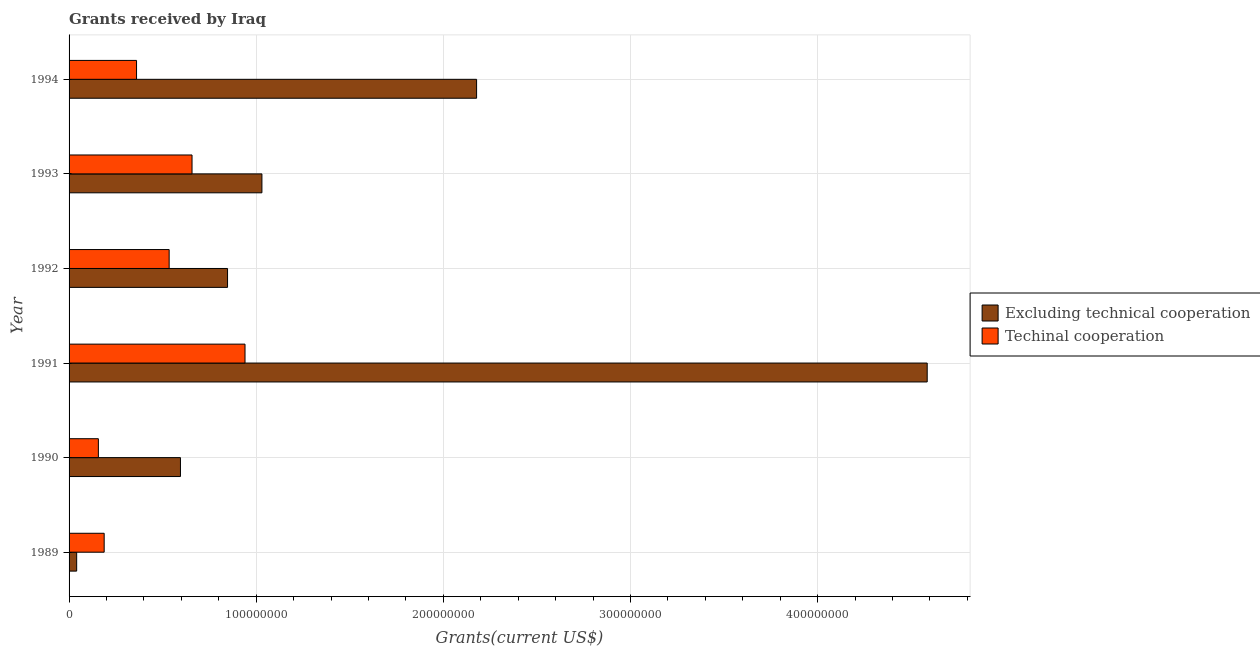Are the number of bars per tick equal to the number of legend labels?
Keep it short and to the point. Yes. What is the label of the 4th group of bars from the top?
Your answer should be very brief. 1991. What is the amount of grants received(excluding technical cooperation) in 1992?
Provide a short and direct response. 8.47e+07. Across all years, what is the maximum amount of grants received(including technical cooperation)?
Give a very brief answer. 9.40e+07. Across all years, what is the minimum amount of grants received(including technical cooperation)?
Provide a short and direct response. 1.57e+07. What is the total amount of grants received(including technical cooperation) in the graph?
Your response must be concise. 2.84e+08. What is the difference between the amount of grants received(excluding technical cooperation) in 1991 and that in 1993?
Your answer should be compact. 3.55e+08. What is the difference between the amount of grants received(including technical cooperation) in 1989 and the amount of grants received(excluding technical cooperation) in 1990?
Provide a short and direct response. -4.08e+07. What is the average amount of grants received(including technical cooperation) per year?
Your answer should be compact. 4.73e+07. In the year 1989, what is the difference between the amount of grants received(including technical cooperation) and amount of grants received(excluding technical cooperation)?
Ensure brevity in your answer.  1.47e+07. What is the ratio of the amount of grants received(including technical cooperation) in 1992 to that in 1994?
Offer a very short reply. 1.48. Is the difference between the amount of grants received(excluding technical cooperation) in 1992 and 1993 greater than the difference between the amount of grants received(including technical cooperation) in 1992 and 1993?
Make the answer very short. No. What is the difference between the highest and the second highest amount of grants received(including technical cooperation)?
Make the answer very short. 2.83e+07. What is the difference between the highest and the lowest amount of grants received(including technical cooperation)?
Your answer should be compact. 7.84e+07. Is the sum of the amount of grants received(including technical cooperation) in 1990 and 1993 greater than the maximum amount of grants received(excluding technical cooperation) across all years?
Your response must be concise. No. What does the 1st bar from the top in 1993 represents?
Your answer should be very brief. Techinal cooperation. What does the 2nd bar from the bottom in 1990 represents?
Keep it short and to the point. Techinal cooperation. How many years are there in the graph?
Offer a very short reply. 6. What is the difference between two consecutive major ticks on the X-axis?
Your answer should be compact. 1.00e+08. Are the values on the major ticks of X-axis written in scientific E-notation?
Keep it short and to the point. No. Does the graph contain any zero values?
Your answer should be compact. No. Does the graph contain grids?
Provide a succinct answer. Yes. How many legend labels are there?
Offer a very short reply. 2. What is the title of the graph?
Your answer should be very brief. Grants received by Iraq. What is the label or title of the X-axis?
Make the answer very short. Grants(current US$). What is the Grants(current US$) in Excluding technical cooperation in 1989?
Provide a short and direct response. 4.06e+06. What is the Grants(current US$) in Techinal cooperation in 1989?
Provide a short and direct response. 1.88e+07. What is the Grants(current US$) in Excluding technical cooperation in 1990?
Give a very brief answer. 5.95e+07. What is the Grants(current US$) of Techinal cooperation in 1990?
Your answer should be very brief. 1.57e+07. What is the Grants(current US$) of Excluding technical cooperation in 1991?
Give a very brief answer. 4.59e+08. What is the Grants(current US$) in Techinal cooperation in 1991?
Make the answer very short. 9.40e+07. What is the Grants(current US$) in Excluding technical cooperation in 1992?
Ensure brevity in your answer.  8.47e+07. What is the Grants(current US$) of Techinal cooperation in 1992?
Your answer should be very brief. 5.35e+07. What is the Grants(current US$) of Excluding technical cooperation in 1993?
Ensure brevity in your answer.  1.03e+08. What is the Grants(current US$) of Techinal cooperation in 1993?
Provide a short and direct response. 6.57e+07. What is the Grants(current US$) of Excluding technical cooperation in 1994?
Your response must be concise. 2.18e+08. What is the Grants(current US$) in Techinal cooperation in 1994?
Provide a succinct answer. 3.61e+07. Across all years, what is the maximum Grants(current US$) in Excluding technical cooperation?
Make the answer very short. 4.59e+08. Across all years, what is the maximum Grants(current US$) of Techinal cooperation?
Offer a terse response. 9.40e+07. Across all years, what is the minimum Grants(current US$) of Excluding technical cooperation?
Provide a short and direct response. 4.06e+06. Across all years, what is the minimum Grants(current US$) in Techinal cooperation?
Make the answer very short. 1.57e+07. What is the total Grants(current US$) of Excluding technical cooperation in the graph?
Your answer should be compact. 9.28e+08. What is the total Grants(current US$) in Techinal cooperation in the graph?
Offer a terse response. 2.84e+08. What is the difference between the Grants(current US$) in Excluding technical cooperation in 1989 and that in 1990?
Ensure brevity in your answer.  -5.55e+07. What is the difference between the Grants(current US$) of Techinal cooperation in 1989 and that in 1990?
Make the answer very short. 3.10e+06. What is the difference between the Grants(current US$) in Excluding technical cooperation in 1989 and that in 1991?
Ensure brevity in your answer.  -4.54e+08. What is the difference between the Grants(current US$) in Techinal cooperation in 1989 and that in 1991?
Your response must be concise. -7.53e+07. What is the difference between the Grants(current US$) of Excluding technical cooperation in 1989 and that in 1992?
Provide a short and direct response. -8.06e+07. What is the difference between the Grants(current US$) in Techinal cooperation in 1989 and that in 1992?
Offer a terse response. -3.47e+07. What is the difference between the Grants(current US$) of Excluding technical cooperation in 1989 and that in 1993?
Your response must be concise. -9.90e+07. What is the difference between the Grants(current US$) of Techinal cooperation in 1989 and that in 1993?
Offer a terse response. -4.69e+07. What is the difference between the Grants(current US$) in Excluding technical cooperation in 1989 and that in 1994?
Offer a terse response. -2.14e+08. What is the difference between the Grants(current US$) in Techinal cooperation in 1989 and that in 1994?
Offer a terse response. -1.73e+07. What is the difference between the Grants(current US$) of Excluding technical cooperation in 1990 and that in 1991?
Your answer should be very brief. -3.99e+08. What is the difference between the Grants(current US$) in Techinal cooperation in 1990 and that in 1991?
Give a very brief answer. -7.84e+07. What is the difference between the Grants(current US$) in Excluding technical cooperation in 1990 and that in 1992?
Make the answer very short. -2.52e+07. What is the difference between the Grants(current US$) in Techinal cooperation in 1990 and that in 1992?
Your answer should be compact. -3.78e+07. What is the difference between the Grants(current US$) of Excluding technical cooperation in 1990 and that in 1993?
Offer a terse response. -4.35e+07. What is the difference between the Grants(current US$) in Techinal cooperation in 1990 and that in 1993?
Ensure brevity in your answer.  -5.00e+07. What is the difference between the Grants(current US$) in Excluding technical cooperation in 1990 and that in 1994?
Offer a very short reply. -1.58e+08. What is the difference between the Grants(current US$) of Techinal cooperation in 1990 and that in 1994?
Offer a very short reply. -2.04e+07. What is the difference between the Grants(current US$) of Excluding technical cooperation in 1991 and that in 1992?
Keep it short and to the point. 3.74e+08. What is the difference between the Grants(current US$) of Techinal cooperation in 1991 and that in 1992?
Make the answer very short. 4.05e+07. What is the difference between the Grants(current US$) in Excluding technical cooperation in 1991 and that in 1993?
Provide a short and direct response. 3.55e+08. What is the difference between the Grants(current US$) of Techinal cooperation in 1991 and that in 1993?
Your answer should be compact. 2.83e+07. What is the difference between the Grants(current US$) of Excluding technical cooperation in 1991 and that in 1994?
Your answer should be very brief. 2.41e+08. What is the difference between the Grants(current US$) in Techinal cooperation in 1991 and that in 1994?
Ensure brevity in your answer.  5.80e+07. What is the difference between the Grants(current US$) in Excluding technical cooperation in 1992 and that in 1993?
Offer a very short reply. -1.84e+07. What is the difference between the Grants(current US$) of Techinal cooperation in 1992 and that in 1993?
Offer a very short reply. -1.22e+07. What is the difference between the Grants(current US$) of Excluding technical cooperation in 1992 and that in 1994?
Your answer should be compact. -1.33e+08. What is the difference between the Grants(current US$) in Techinal cooperation in 1992 and that in 1994?
Provide a short and direct response. 1.74e+07. What is the difference between the Grants(current US$) in Excluding technical cooperation in 1993 and that in 1994?
Make the answer very short. -1.15e+08. What is the difference between the Grants(current US$) in Techinal cooperation in 1993 and that in 1994?
Keep it short and to the point. 2.96e+07. What is the difference between the Grants(current US$) in Excluding technical cooperation in 1989 and the Grants(current US$) in Techinal cooperation in 1990?
Give a very brief answer. -1.16e+07. What is the difference between the Grants(current US$) of Excluding technical cooperation in 1989 and the Grants(current US$) of Techinal cooperation in 1991?
Ensure brevity in your answer.  -9.00e+07. What is the difference between the Grants(current US$) of Excluding technical cooperation in 1989 and the Grants(current US$) of Techinal cooperation in 1992?
Offer a terse response. -4.94e+07. What is the difference between the Grants(current US$) of Excluding technical cooperation in 1989 and the Grants(current US$) of Techinal cooperation in 1993?
Your answer should be very brief. -6.16e+07. What is the difference between the Grants(current US$) of Excluding technical cooperation in 1989 and the Grants(current US$) of Techinal cooperation in 1994?
Provide a short and direct response. -3.20e+07. What is the difference between the Grants(current US$) of Excluding technical cooperation in 1990 and the Grants(current US$) of Techinal cooperation in 1991?
Offer a terse response. -3.45e+07. What is the difference between the Grants(current US$) in Excluding technical cooperation in 1990 and the Grants(current US$) in Techinal cooperation in 1992?
Your answer should be very brief. 6.04e+06. What is the difference between the Grants(current US$) in Excluding technical cooperation in 1990 and the Grants(current US$) in Techinal cooperation in 1993?
Offer a terse response. -6.18e+06. What is the difference between the Grants(current US$) in Excluding technical cooperation in 1990 and the Grants(current US$) in Techinal cooperation in 1994?
Keep it short and to the point. 2.35e+07. What is the difference between the Grants(current US$) of Excluding technical cooperation in 1991 and the Grants(current US$) of Techinal cooperation in 1992?
Provide a succinct answer. 4.05e+08. What is the difference between the Grants(current US$) of Excluding technical cooperation in 1991 and the Grants(current US$) of Techinal cooperation in 1993?
Make the answer very short. 3.93e+08. What is the difference between the Grants(current US$) of Excluding technical cooperation in 1991 and the Grants(current US$) of Techinal cooperation in 1994?
Your answer should be very brief. 4.22e+08. What is the difference between the Grants(current US$) of Excluding technical cooperation in 1992 and the Grants(current US$) of Techinal cooperation in 1993?
Give a very brief answer. 1.90e+07. What is the difference between the Grants(current US$) of Excluding technical cooperation in 1992 and the Grants(current US$) of Techinal cooperation in 1994?
Your response must be concise. 4.86e+07. What is the difference between the Grants(current US$) in Excluding technical cooperation in 1993 and the Grants(current US$) in Techinal cooperation in 1994?
Provide a short and direct response. 6.70e+07. What is the average Grants(current US$) of Excluding technical cooperation per year?
Provide a short and direct response. 1.55e+08. What is the average Grants(current US$) of Techinal cooperation per year?
Give a very brief answer. 4.73e+07. In the year 1989, what is the difference between the Grants(current US$) in Excluding technical cooperation and Grants(current US$) in Techinal cooperation?
Offer a terse response. -1.47e+07. In the year 1990, what is the difference between the Grants(current US$) in Excluding technical cooperation and Grants(current US$) in Techinal cooperation?
Offer a very short reply. 4.39e+07. In the year 1991, what is the difference between the Grants(current US$) of Excluding technical cooperation and Grants(current US$) of Techinal cooperation?
Make the answer very short. 3.65e+08. In the year 1992, what is the difference between the Grants(current US$) of Excluding technical cooperation and Grants(current US$) of Techinal cooperation?
Provide a succinct answer. 3.12e+07. In the year 1993, what is the difference between the Grants(current US$) of Excluding technical cooperation and Grants(current US$) of Techinal cooperation?
Provide a short and direct response. 3.74e+07. In the year 1994, what is the difference between the Grants(current US$) of Excluding technical cooperation and Grants(current US$) of Techinal cooperation?
Your response must be concise. 1.82e+08. What is the ratio of the Grants(current US$) in Excluding technical cooperation in 1989 to that in 1990?
Your answer should be compact. 0.07. What is the ratio of the Grants(current US$) in Techinal cooperation in 1989 to that in 1990?
Offer a terse response. 1.2. What is the ratio of the Grants(current US$) in Excluding technical cooperation in 1989 to that in 1991?
Ensure brevity in your answer.  0.01. What is the ratio of the Grants(current US$) of Techinal cooperation in 1989 to that in 1991?
Your answer should be very brief. 0.2. What is the ratio of the Grants(current US$) of Excluding technical cooperation in 1989 to that in 1992?
Give a very brief answer. 0.05. What is the ratio of the Grants(current US$) in Techinal cooperation in 1989 to that in 1992?
Give a very brief answer. 0.35. What is the ratio of the Grants(current US$) in Excluding technical cooperation in 1989 to that in 1993?
Offer a very short reply. 0.04. What is the ratio of the Grants(current US$) in Techinal cooperation in 1989 to that in 1993?
Keep it short and to the point. 0.29. What is the ratio of the Grants(current US$) in Excluding technical cooperation in 1989 to that in 1994?
Provide a short and direct response. 0.02. What is the ratio of the Grants(current US$) in Techinal cooperation in 1989 to that in 1994?
Give a very brief answer. 0.52. What is the ratio of the Grants(current US$) in Excluding technical cooperation in 1990 to that in 1991?
Provide a succinct answer. 0.13. What is the ratio of the Grants(current US$) of Techinal cooperation in 1990 to that in 1991?
Your answer should be compact. 0.17. What is the ratio of the Grants(current US$) in Excluding technical cooperation in 1990 to that in 1992?
Keep it short and to the point. 0.7. What is the ratio of the Grants(current US$) of Techinal cooperation in 1990 to that in 1992?
Ensure brevity in your answer.  0.29. What is the ratio of the Grants(current US$) of Excluding technical cooperation in 1990 to that in 1993?
Make the answer very short. 0.58. What is the ratio of the Grants(current US$) in Techinal cooperation in 1990 to that in 1993?
Offer a terse response. 0.24. What is the ratio of the Grants(current US$) in Excluding technical cooperation in 1990 to that in 1994?
Ensure brevity in your answer.  0.27. What is the ratio of the Grants(current US$) of Techinal cooperation in 1990 to that in 1994?
Your answer should be compact. 0.43. What is the ratio of the Grants(current US$) in Excluding technical cooperation in 1991 to that in 1992?
Provide a succinct answer. 5.42. What is the ratio of the Grants(current US$) of Techinal cooperation in 1991 to that in 1992?
Your answer should be very brief. 1.76. What is the ratio of the Grants(current US$) in Excluding technical cooperation in 1991 to that in 1993?
Your answer should be compact. 4.45. What is the ratio of the Grants(current US$) of Techinal cooperation in 1991 to that in 1993?
Make the answer very short. 1.43. What is the ratio of the Grants(current US$) of Excluding technical cooperation in 1991 to that in 1994?
Provide a short and direct response. 2.11. What is the ratio of the Grants(current US$) of Techinal cooperation in 1991 to that in 1994?
Provide a short and direct response. 2.61. What is the ratio of the Grants(current US$) in Excluding technical cooperation in 1992 to that in 1993?
Ensure brevity in your answer.  0.82. What is the ratio of the Grants(current US$) of Techinal cooperation in 1992 to that in 1993?
Your answer should be compact. 0.81. What is the ratio of the Grants(current US$) in Excluding technical cooperation in 1992 to that in 1994?
Your response must be concise. 0.39. What is the ratio of the Grants(current US$) of Techinal cooperation in 1992 to that in 1994?
Offer a terse response. 1.48. What is the ratio of the Grants(current US$) of Excluding technical cooperation in 1993 to that in 1994?
Make the answer very short. 0.47. What is the ratio of the Grants(current US$) of Techinal cooperation in 1993 to that in 1994?
Make the answer very short. 1.82. What is the difference between the highest and the second highest Grants(current US$) of Excluding technical cooperation?
Provide a short and direct response. 2.41e+08. What is the difference between the highest and the second highest Grants(current US$) in Techinal cooperation?
Your answer should be compact. 2.83e+07. What is the difference between the highest and the lowest Grants(current US$) of Excluding technical cooperation?
Keep it short and to the point. 4.54e+08. What is the difference between the highest and the lowest Grants(current US$) of Techinal cooperation?
Keep it short and to the point. 7.84e+07. 